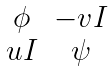Convert formula to latex. <formula><loc_0><loc_0><loc_500><loc_500>\begin{matrix} \phi & - v I \\ u I & \psi \end{matrix}</formula> 